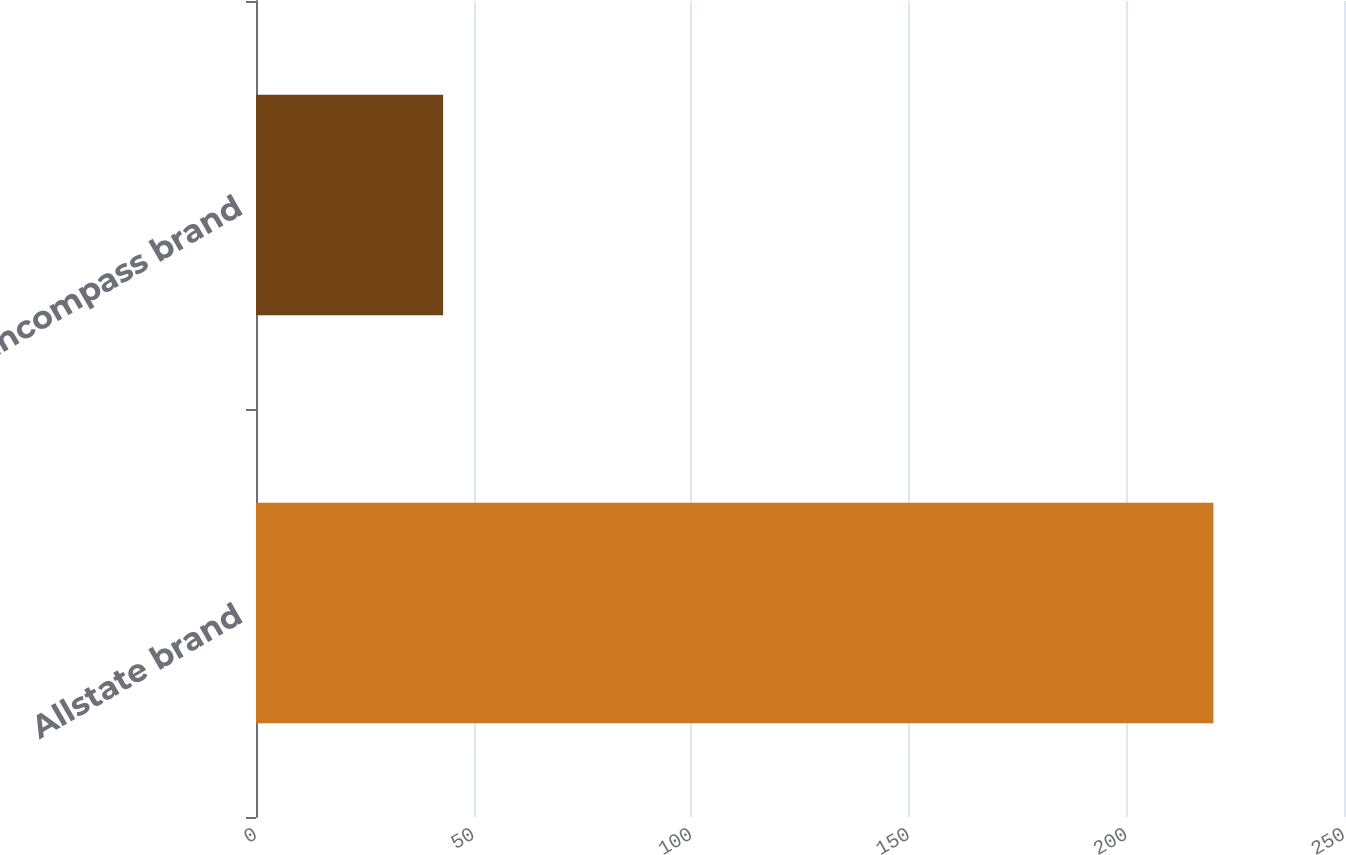Convert chart to OTSL. <chart><loc_0><loc_0><loc_500><loc_500><bar_chart><fcel>Allstate brand<fcel>Encompass brand<nl><fcel>220<fcel>43<nl></chart> 